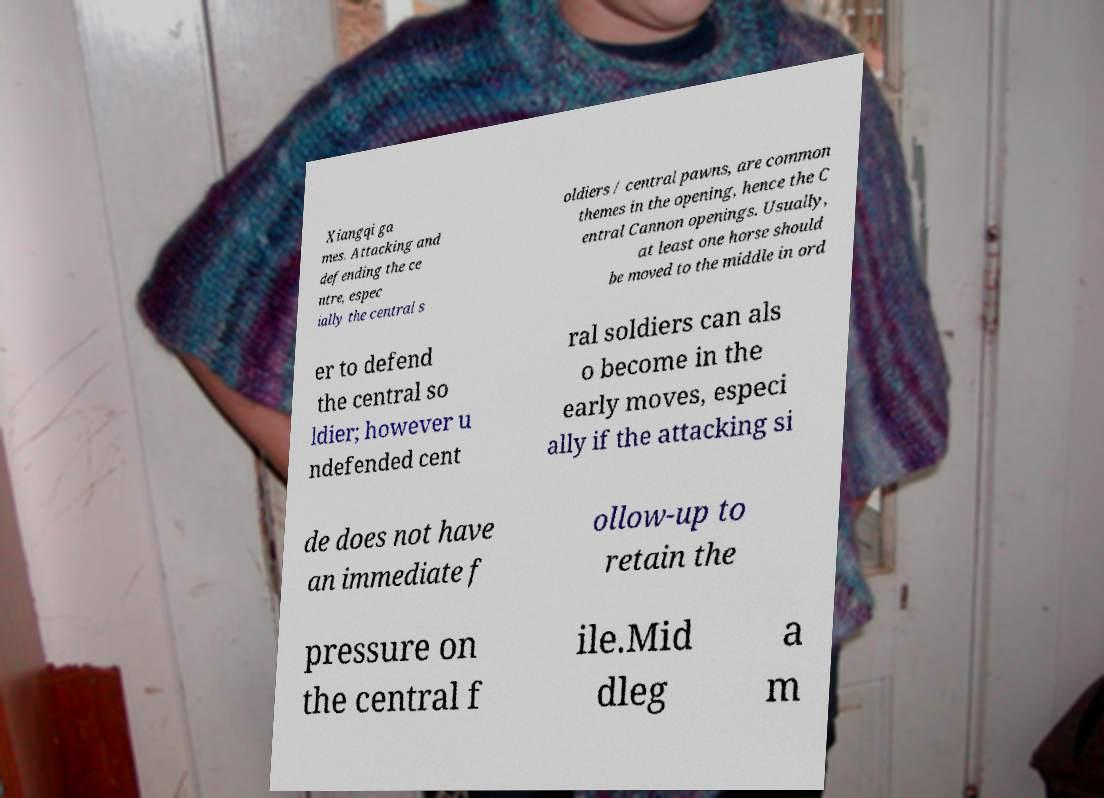Could you extract and type out the text from this image? Xiangqi ga mes. Attacking and defending the ce ntre, espec ially the central s oldiers / central pawns, are common themes in the opening, hence the C entral Cannon openings. Usually, at least one horse should be moved to the middle in ord er to defend the central so ldier; however u ndefended cent ral soldiers can als o become in the early moves, especi ally if the attacking si de does not have an immediate f ollow-up to retain the pressure on the central f ile.Mid dleg a m 